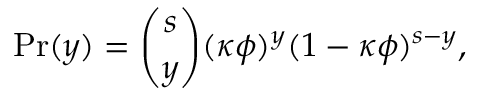<formula> <loc_0><loc_0><loc_500><loc_500>P r ( y ) = \binom { s } { y } ( \kappa \phi ) ^ { y } ( 1 - \kappa \phi ) ^ { s - y } ,</formula> 